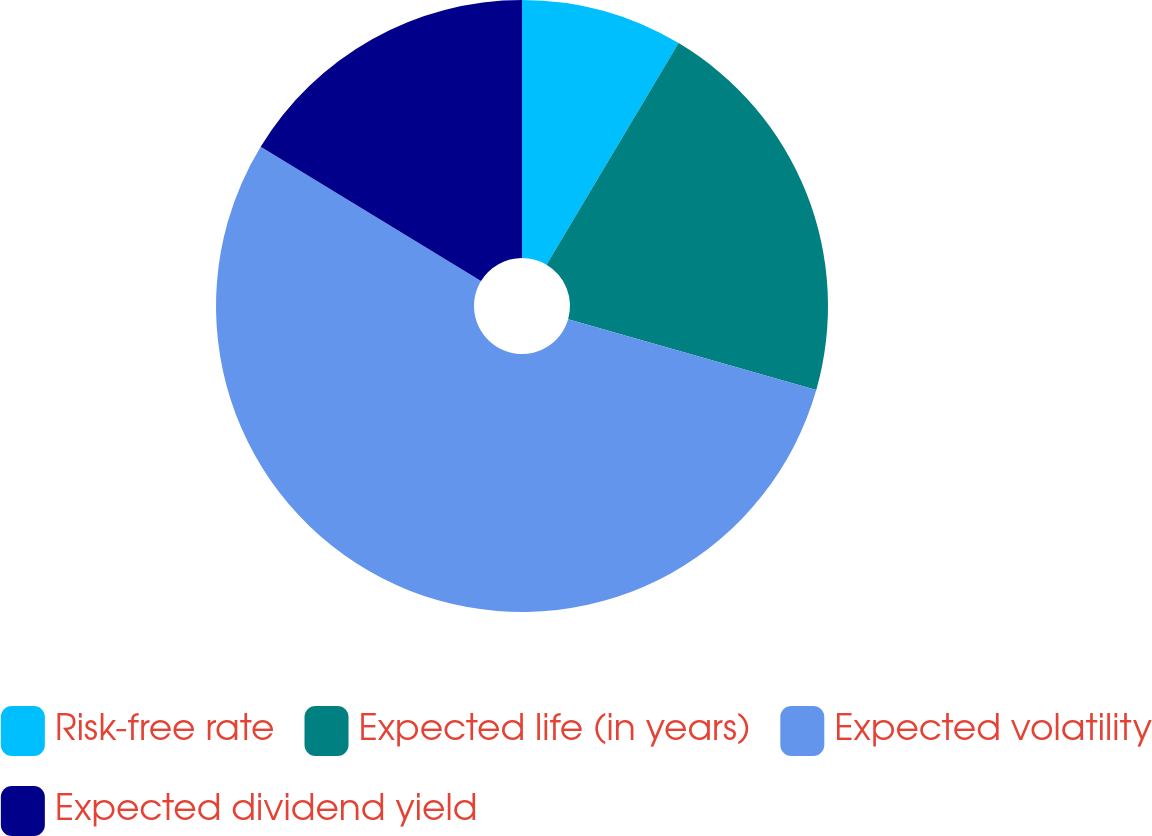Convert chart. <chart><loc_0><loc_0><loc_500><loc_500><pie_chart><fcel>Risk-free rate<fcel>Expected life (in years)<fcel>Expected volatility<fcel>Expected dividend yield<nl><fcel>8.55%<fcel>20.87%<fcel>54.29%<fcel>16.29%<nl></chart> 